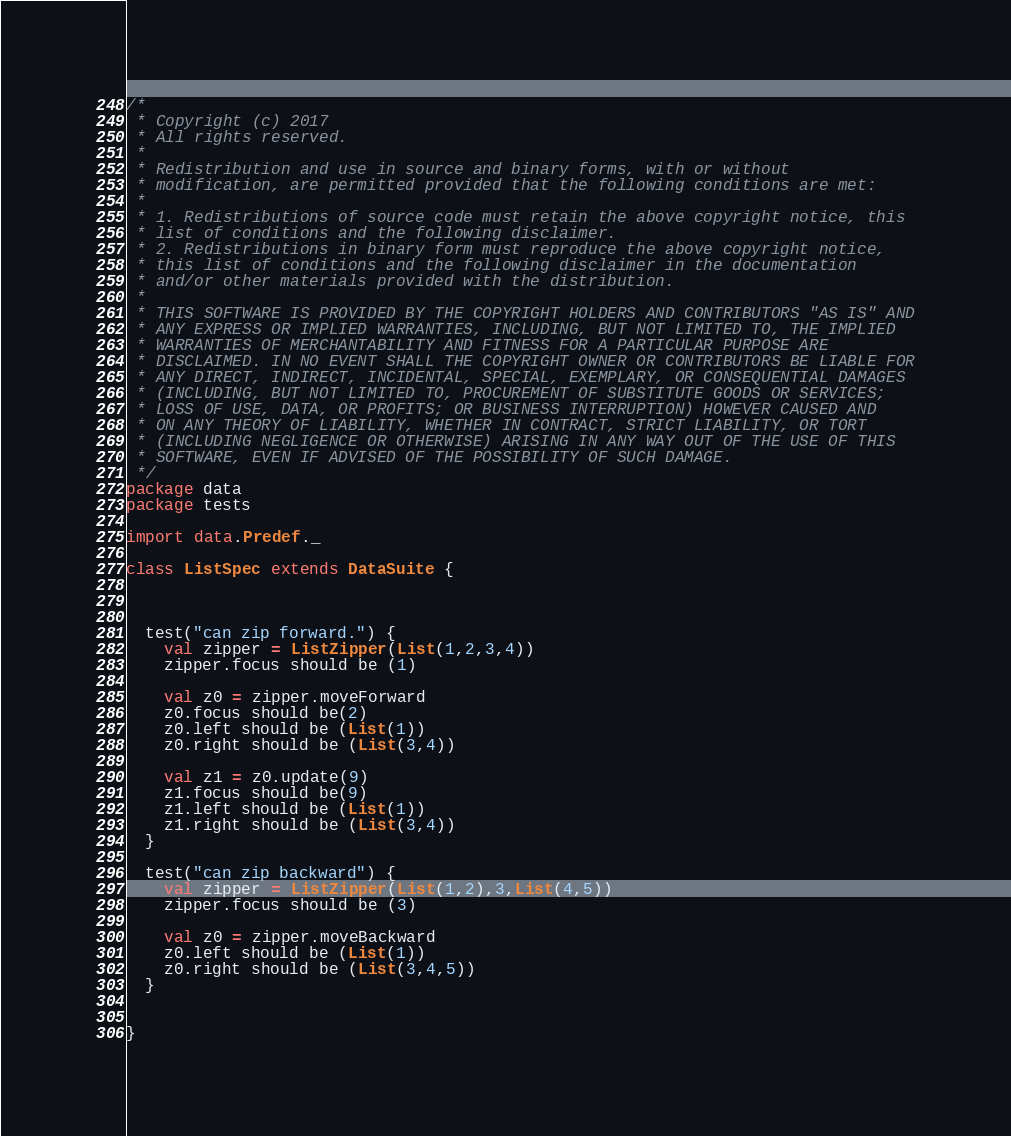<code> <loc_0><loc_0><loc_500><loc_500><_Scala_>/*
 * Copyright (c) 2017
 * All rights reserved.
 *
 * Redistribution and use in source and binary forms, with or without
 * modification, are permitted provided that the following conditions are met:
 *
 * 1. Redistributions of source code must retain the above copyright notice, this
 * list of conditions and the following disclaimer.
 * 2. Redistributions in binary form must reproduce the above copyright notice,
 * this list of conditions and the following disclaimer in the documentation
 * and/or other materials provided with the distribution.
 *
 * THIS SOFTWARE IS PROVIDED BY THE COPYRIGHT HOLDERS AND CONTRIBUTORS "AS IS" AND
 * ANY EXPRESS OR IMPLIED WARRANTIES, INCLUDING, BUT NOT LIMITED TO, THE IMPLIED
 * WARRANTIES OF MERCHANTABILITY AND FITNESS FOR A PARTICULAR PURPOSE ARE
 * DISCLAIMED. IN NO EVENT SHALL THE COPYRIGHT OWNER OR CONTRIBUTORS BE LIABLE FOR
 * ANY DIRECT, INDIRECT, INCIDENTAL, SPECIAL, EXEMPLARY, OR CONSEQUENTIAL DAMAGES
 * (INCLUDING, BUT NOT LIMITED TO, PROCUREMENT OF SUBSTITUTE GOODS OR SERVICES;
 * LOSS OF USE, DATA, OR PROFITS; OR BUSINESS INTERRUPTION) HOWEVER CAUSED AND
 * ON ANY THEORY OF LIABILITY, WHETHER IN CONTRACT, STRICT LIABILITY, OR TORT
 * (INCLUDING NEGLIGENCE OR OTHERWISE) ARISING IN ANY WAY OUT OF THE USE OF THIS
 * SOFTWARE, EVEN IF ADVISED OF THE POSSIBILITY OF SUCH DAMAGE.
 */
package data
package tests

import data.Predef._

class ListSpec extends DataSuite {



  test("can zip forward.") {
    val zipper = ListZipper(List(1,2,3,4))
    zipper.focus should be (1)

    val z0 = zipper.moveForward
    z0.focus should be(2)
    z0.left should be (List(1))
    z0.right should be (List(3,4))

    val z1 = z0.update(9)
    z1.focus should be(9)
    z1.left should be (List(1))
    z1.right should be (List(3,4))
  }

  test("can zip backward") {
    val zipper = ListZipper(List(1,2),3,List(4,5))
    zipper.focus should be (3)

    val z0 = zipper.moveBackward
    z0.left should be (List(1))
    z0.right should be (List(3,4,5))
  }


}
</code> 